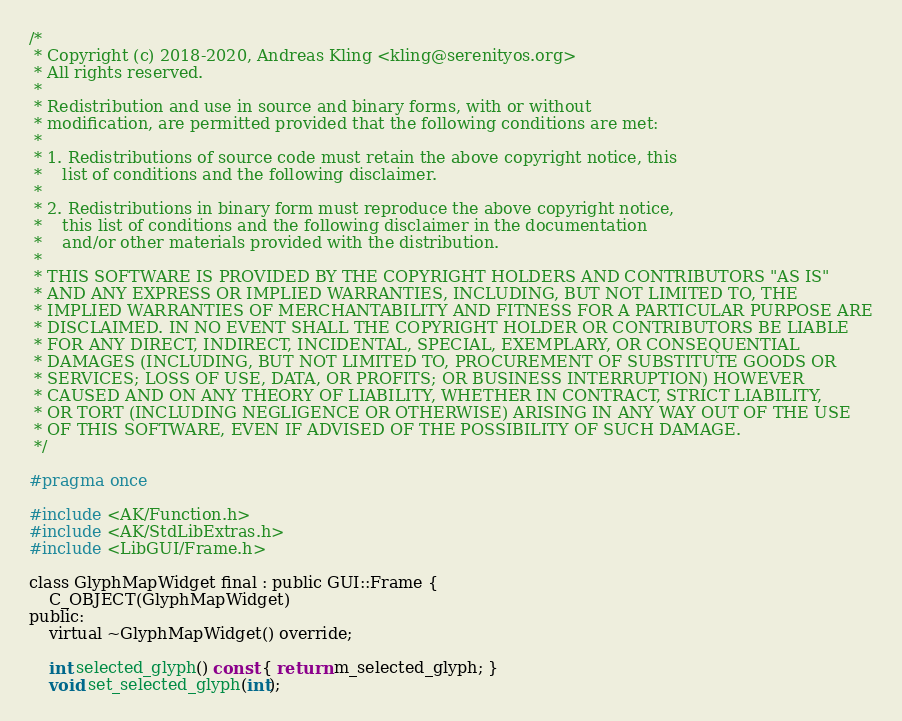Convert code to text. <code><loc_0><loc_0><loc_500><loc_500><_C_>/*
 * Copyright (c) 2018-2020, Andreas Kling <kling@serenityos.org>
 * All rights reserved.
 *
 * Redistribution and use in source and binary forms, with or without
 * modification, are permitted provided that the following conditions are met:
 *
 * 1. Redistributions of source code must retain the above copyright notice, this
 *    list of conditions and the following disclaimer.
 *
 * 2. Redistributions in binary form must reproduce the above copyright notice,
 *    this list of conditions and the following disclaimer in the documentation
 *    and/or other materials provided with the distribution.
 *
 * THIS SOFTWARE IS PROVIDED BY THE COPYRIGHT HOLDERS AND CONTRIBUTORS "AS IS"
 * AND ANY EXPRESS OR IMPLIED WARRANTIES, INCLUDING, BUT NOT LIMITED TO, THE
 * IMPLIED WARRANTIES OF MERCHANTABILITY AND FITNESS FOR A PARTICULAR PURPOSE ARE
 * DISCLAIMED. IN NO EVENT SHALL THE COPYRIGHT HOLDER OR CONTRIBUTORS BE LIABLE
 * FOR ANY DIRECT, INDIRECT, INCIDENTAL, SPECIAL, EXEMPLARY, OR CONSEQUENTIAL
 * DAMAGES (INCLUDING, BUT NOT LIMITED TO, PROCUREMENT OF SUBSTITUTE GOODS OR
 * SERVICES; LOSS OF USE, DATA, OR PROFITS; OR BUSINESS INTERRUPTION) HOWEVER
 * CAUSED AND ON ANY THEORY OF LIABILITY, WHETHER IN CONTRACT, STRICT LIABILITY,
 * OR TORT (INCLUDING NEGLIGENCE OR OTHERWISE) ARISING IN ANY WAY OUT OF THE USE
 * OF THIS SOFTWARE, EVEN IF ADVISED OF THE POSSIBILITY OF SUCH DAMAGE.
 */

#pragma once

#include <AK/Function.h>
#include <AK/StdLibExtras.h>
#include <LibGUI/Frame.h>

class GlyphMapWidget final : public GUI::Frame {
    C_OBJECT(GlyphMapWidget)
public:
    virtual ~GlyphMapWidget() override;

    int selected_glyph() const { return m_selected_glyph; }
    void set_selected_glyph(int);
</code> 